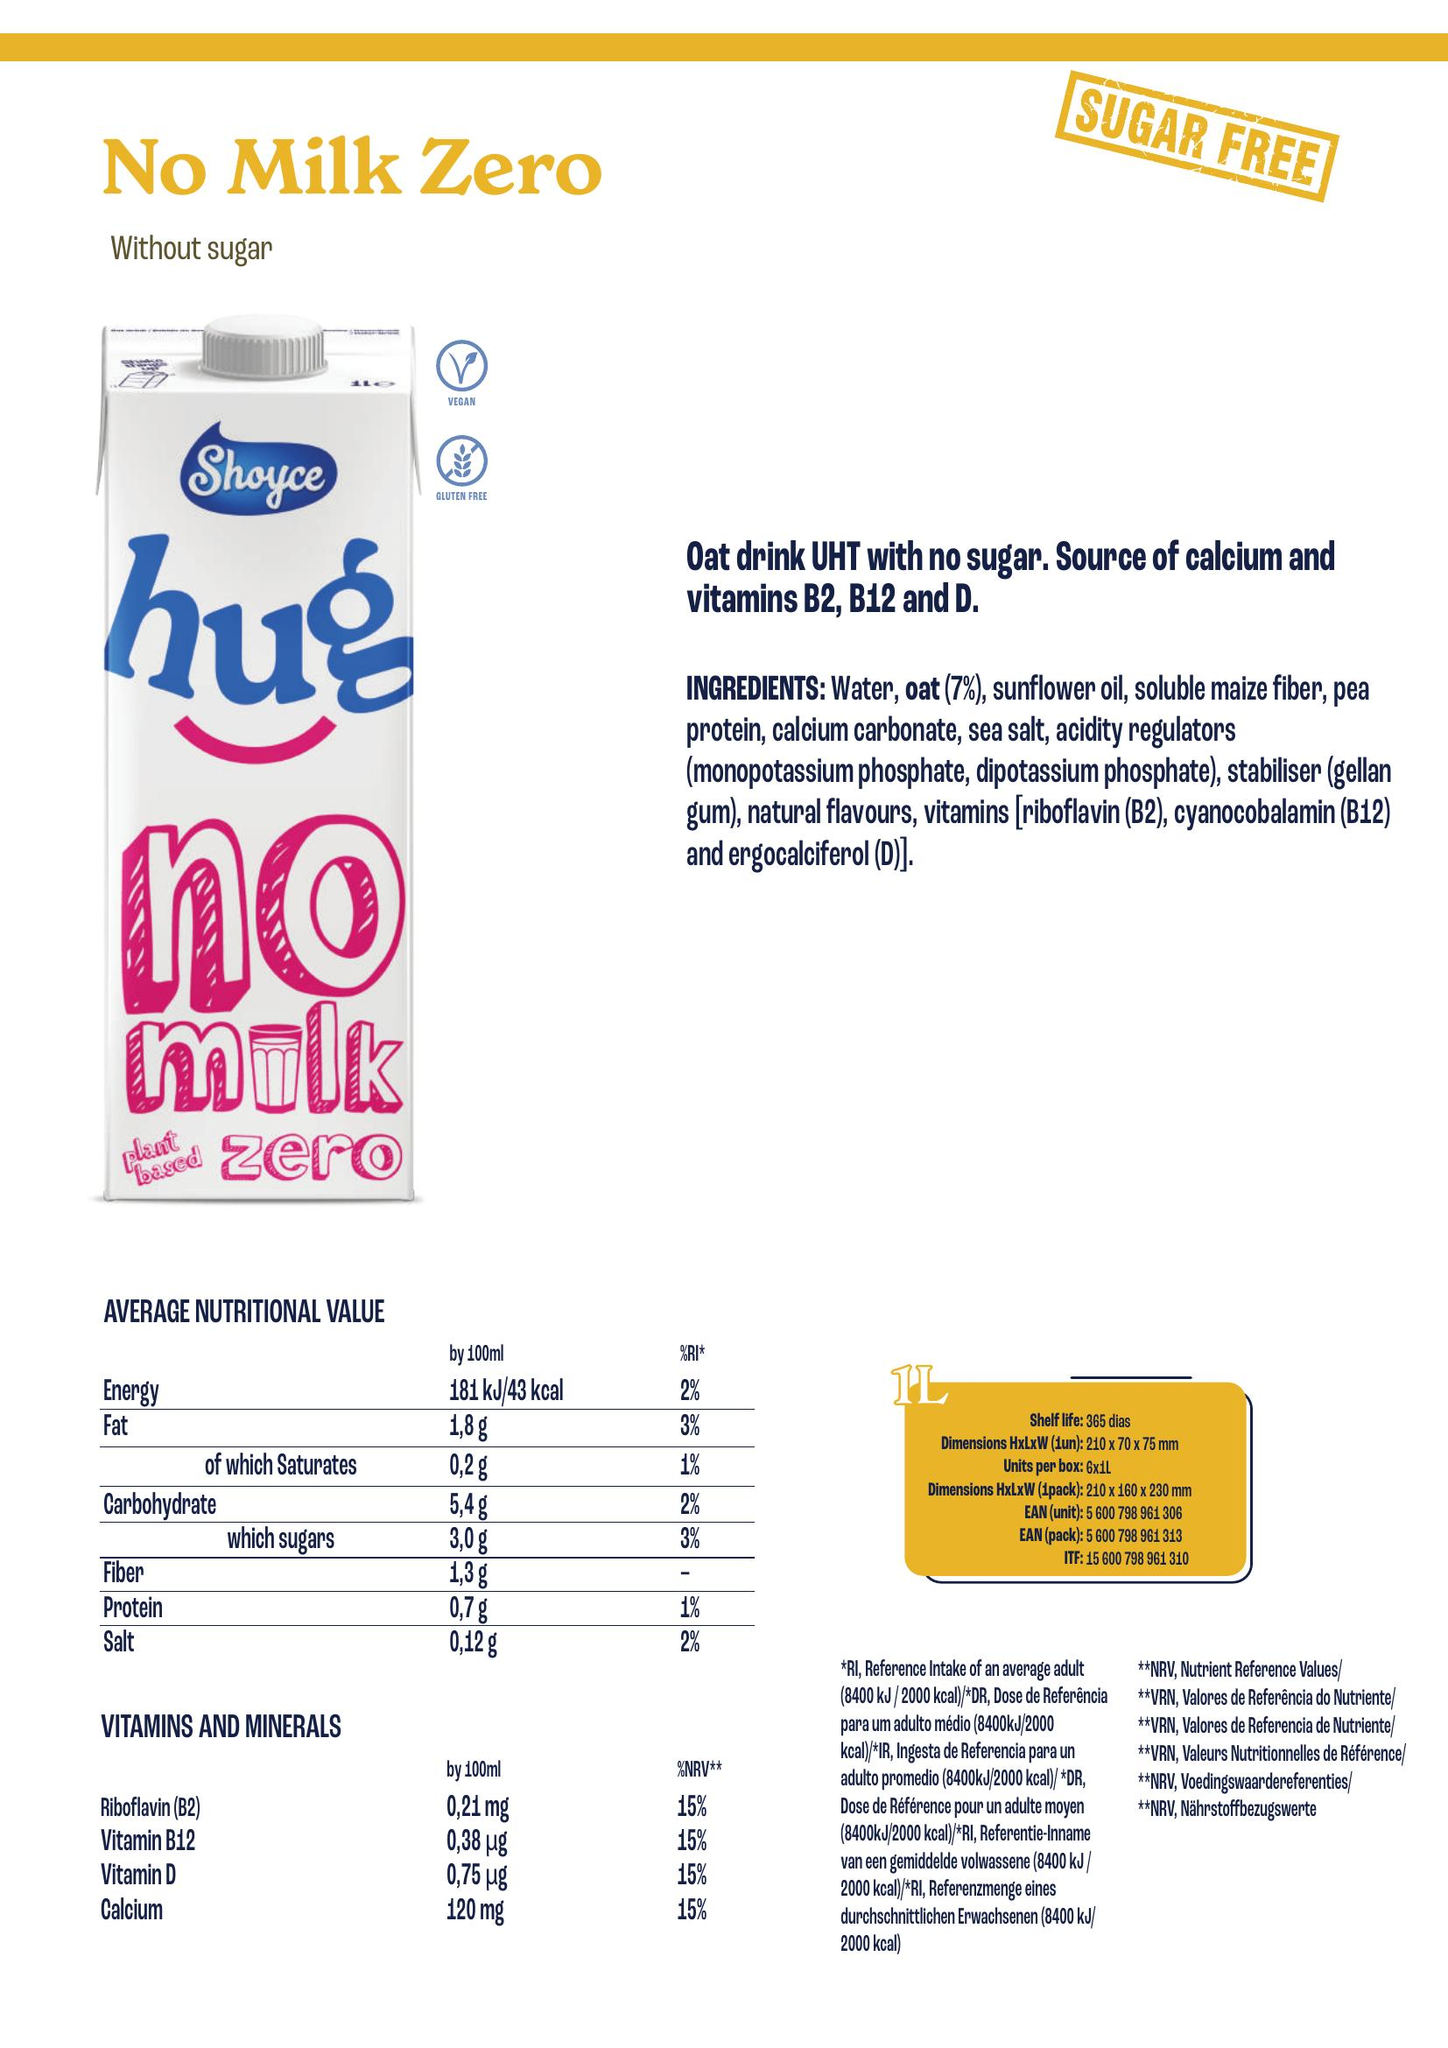From the image, create a nutrition table include as columns the different nutrient present, add the unit associated with the nutrient and append the volume considered for the values in [] after the nutrient name, for energy only consider the information for kcal and isolate the associate value accordingly. Add a column for the product name located in the top left, add a column for the ingredients associated with the product, also add a column for allergens which are ingredients in bold listed in the ingredients.  Write the result as python code to build a dataframe
 import pandas as pd

data = {
    'Product Name': ['No Milk Zero'],
    'Nutrient [per 100ml]': ['Energy', 'Fat', 'of which Saturates', 'Carbohydrate', 'which sugars', 'Fibre', 'Protein', 'Salt'],
    'Value': [181, 1.8, 0.2, 5.4, 3.0, 1.4, 0.7, 0.12],
    'Unit': ['kcal', 'g', 'g', 'g', 'g', 'g', 'g', 'g'],
    'Vitamins and Minerals [per 100ml]': ['Riboflavin (B2)', 'Vitamin B12', 'Vitamin D', 'Calcium'],
    'Value (Vitamins and Minerals)': [0.21, 0.38, 0.75, 120.0],
    'Unit (Vitamins and Minerals)': ['mg', 'μg', 'μg', 'mg'],
    'Ingredients': ['Water, oat (7%), sunflower oil, soluble maize fiber, pea protein, calcium carbonate, sea salt, acidity regulators (monopotassium phosphate, dipotassium phosphate), stabiliser (gellan gum), natural flavours, vitamins [riboflavin (B2), cyanocobalamin (B12) and ergocalciferol (D)].'],
    'Allergens': ['Pea protein']
}

df = pd.DataFrame(data)
print(df) 